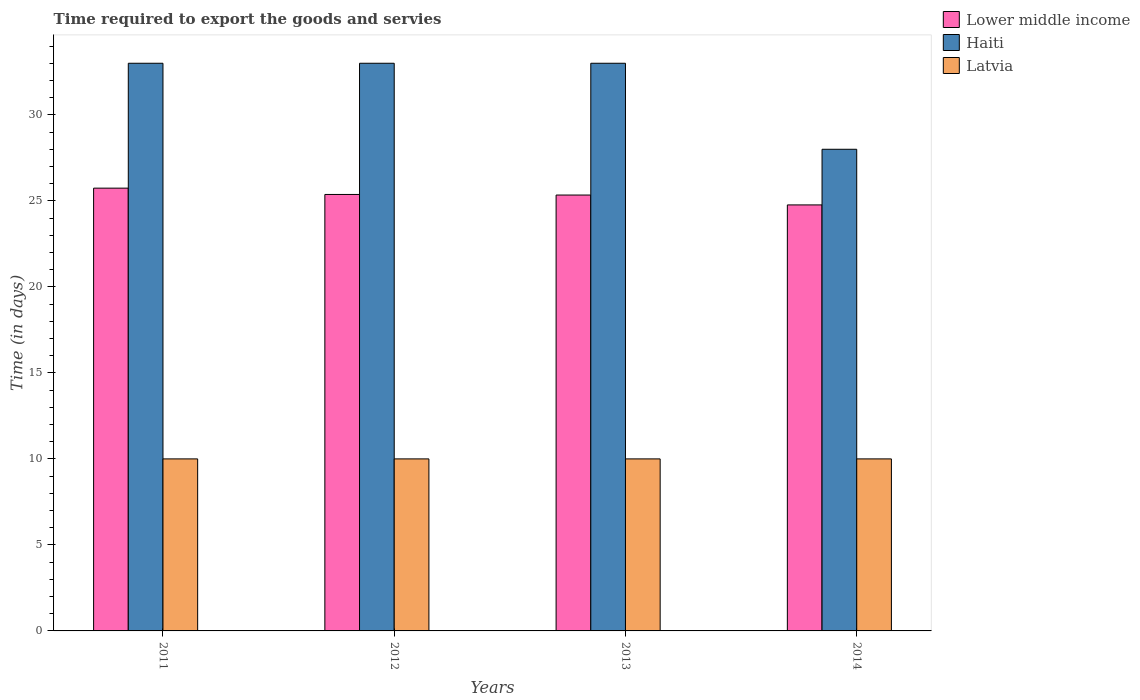Are the number of bars per tick equal to the number of legend labels?
Ensure brevity in your answer.  Yes. Are the number of bars on each tick of the X-axis equal?
Your response must be concise. Yes. What is the number of days required to export the goods and services in Haiti in 2011?
Give a very brief answer. 33. Across all years, what is the maximum number of days required to export the goods and services in Lower middle income?
Keep it short and to the point. 25.74. Across all years, what is the minimum number of days required to export the goods and services in Latvia?
Your answer should be very brief. 10. In which year was the number of days required to export the goods and services in Latvia minimum?
Your answer should be very brief. 2011. What is the total number of days required to export the goods and services in Haiti in the graph?
Offer a very short reply. 127. What is the difference between the number of days required to export the goods and services in Lower middle income in 2013 and that in 2014?
Provide a short and direct response. 0.57. What is the difference between the number of days required to export the goods and services in Latvia in 2011 and the number of days required to export the goods and services in Lower middle income in 2012?
Offer a terse response. -15.37. What is the average number of days required to export the goods and services in Latvia per year?
Give a very brief answer. 10. In the year 2013, what is the difference between the number of days required to export the goods and services in Lower middle income and number of days required to export the goods and services in Haiti?
Your answer should be compact. -7.66. In how many years, is the number of days required to export the goods and services in Latvia greater than 7 days?
Provide a succinct answer. 4. What is the ratio of the number of days required to export the goods and services in Haiti in 2012 to that in 2013?
Your answer should be very brief. 1. Is the number of days required to export the goods and services in Lower middle income in 2011 less than that in 2013?
Keep it short and to the point. No. What is the difference between the highest and the second highest number of days required to export the goods and services in Lower middle income?
Your answer should be very brief. 0.37. Is the sum of the number of days required to export the goods and services in Haiti in 2012 and 2013 greater than the maximum number of days required to export the goods and services in Latvia across all years?
Offer a terse response. Yes. What does the 3rd bar from the left in 2011 represents?
Provide a short and direct response. Latvia. What does the 1st bar from the right in 2014 represents?
Provide a succinct answer. Latvia. Is it the case that in every year, the sum of the number of days required to export the goods and services in Haiti and number of days required to export the goods and services in Lower middle income is greater than the number of days required to export the goods and services in Latvia?
Offer a terse response. Yes. How many bars are there?
Offer a terse response. 12. How many years are there in the graph?
Make the answer very short. 4. Does the graph contain grids?
Offer a terse response. No. How many legend labels are there?
Your answer should be very brief. 3. What is the title of the graph?
Your response must be concise. Time required to export the goods and servies. Does "Chile" appear as one of the legend labels in the graph?
Make the answer very short. No. What is the label or title of the Y-axis?
Offer a terse response. Time (in days). What is the Time (in days) of Lower middle income in 2011?
Provide a short and direct response. 25.74. What is the Time (in days) of Haiti in 2011?
Provide a succinct answer. 33. What is the Time (in days) in Lower middle income in 2012?
Offer a very short reply. 25.37. What is the Time (in days) in Lower middle income in 2013?
Your answer should be compact. 25.34. What is the Time (in days) of Lower middle income in 2014?
Provide a short and direct response. 24.76. What is the Time (in days) in Latvia in 2014?
Offer a terse response. 10. Across all years, what is the maximum Time (in days) of Lower middle income?
Offer a terse response. 25.74. Across all years, what is the maximum Time (in days) in Latvia?
Provide a short and direct response. 10. Across all years, what is the minimum Time (in days) of Lower middle income?
Give a very brief answer. 24.76. Across all years, what is the minimum Time (in days) in Haiti?
Your answer should be very brief. 28. What is the total Time (in days) in Lower middle income in the graph?
Your answer should be compact. 101.22. What is the total Time (in days) of Haiti in the graph?
Offer a terse response. 127. What is the total Time (in days) of Latvia in the graph?
Your response must be concise. 40. What is the difference between the Time (in days) of Lower middle income in 2011 and that in 2012?
Keep it short and to the point. 0.37. What is the difference between the Time (in days) in Latvia in 2011 and that in 2012?
Keep it short and to the point. 0. What is the difference between the Time (in days) in Lower middle income in 2011 and that in 2013?
Your answer should be very brief. 0.4. What is the difference between the Time (in days) in Lower middle income in 2011 and that in 2014?
Make the answer very short. 0.98. What is the difference between the Time (in days) in Latvia in 2012 and that in 2013?
Ensure brevity in your answer.  0. What is the difference between the Time (in days) in Lower middle income in 2012 and that in 2014?
Offer a very short reply. 0.61. What is the difference between the Time (in days) of Lower middle income in 2013 and that in 2014?
Give a very brief answer. 0.57. What is the difference between the Time (in days) in Haiti in 2013 and that in 2014?
Your answer should be very brief. 5. What is the difference between the Time (in days) in Lower middle income in 2011 and the Time (in days) in Haiti in 2012?
Your response must be concise. -7.26. What is the difference between the Time (in days) of Lower middle income in 2011 and the Time (in days) of Latvia in 2012?
Your response must be concise. 15.74. What is the difference between the Time (in days) of Lower middle income in 2011 and the Time (in days) of Haiti in 2013?
Your answer should be compact. -7.26. What is the difference between the Time (in days) of Lower middle income in 2011 and the Time (in days) of Latvia in 2013?
Your answer should be compact. 15.74. What is the difference between the Time (in days) of Haiti in 2011 and the Time (in days) of Latvia in 2013?
Your answer should be very brief. 23. What is the difference between the Time (in days) in Lower middle income in 2011 and the Time (in days) in Haiti in 2014?
Ensure brevity in your answer.  -2.26. What is the difference between the Time (in days) in Lower middle income in 2011 and the Time (in days) in Latvia in 2014?
Offer a terse response. 15.74. What is the difference between the Time (in days) in Lower middle income in 2012 and the Time (in days) in Haiti in 2013?
Your answer should be compact. -7.63. What is the difference between the Time (in days) of Lower middle income in 2012 and the Time (in days) of Latvia in 2013?
Your answer should be compact. 15.37. What is the difference between the Time (in days) of Haiti in 2012 and the Time (in days) of Latvia in 2013?
Your answer should be compact. 23. What is the difference between the Time (in days) in Lower middle income in 2012 and the Time (in days) in Haiti in 2014?
Offer a terse response. -2.63. What is the difference between the Time (in days) in Lower middle income in 2012 and the Time (in days) in Latvia in 2014?
Offer a very short reply. 15.37. What is the difference between the Time (in days) in Lower middle income in 2013 and the Time (in days) in Haiti in 2014?
Your answer should be very brief. -2.66. What is the difference between the Time (in days) in Lower middle income in 2013 and the Time (in days) in Latvia in 2014?
Offer a very short reply. 15.34. What is the difference between the Time (in days) of Haiti in 2013 and the Time (in days) of Latvia in 2014?
Offer a terse response. 23. What is the average Time (in days) of Lower middle income per year?
Your response must be concise. 25.3. What is the average Time (in days) of Haiti per year?
Your answer should be very brief. 31.75. What is the average Time (in days) in Latvia per year?
Make the answer very short. 10. In the year 2011, what is the difference between the Time (in days) of Lower middle income and Time (in days) of Haiti?
Provide a short and direct response. -7.26. In the year 2011, what is the difference between the Time (in days) of Lower middle income and Time (in days) of Latvia?
Your answer should be compact. 15.74. In the year 2011, what is the difference between the Time (in days) in Haiti and Time (in days) in Latvia?
Give a very brief answer. 23. In the year 2012, what is the difference between the Time (in days) of Lower middle income and Time (in days) of Haiti?
Give a very brief answer. -7.63. In the year 2012, what is the difference between the Time (in days) in Lower middle income and Time (in days) in Latvia?
Give a very brief answer. 15.37. In the year 2013, what is the difference between the Time (in days) in Lower middle income and Time (in days) in Haiti?
Your answer should be very brief. -7.66. In the year 2013, what is the difference between the Time (in days) in Lower middle income and Time (in days) in Latvia?
Your answer should be compact. 15.34. In the year 2014, what is the difference between the Time (in days) in Lower middle income and Time (in days) in Haiti?
Offer a very short reply. -3.24. In the year 2014, what is the difference between the Time (in days) of Lower middle income and Time (in days) of Latvia?
Give a very brief answer. 14.76. What is the ratio of the Time (in days) in Lower middle income in 2011 to that in 2012?
Give a very brief answer. 1.01. What is the ratio of the Time (in days) in Haiti in 2011 to that in 2012?
Give a very brief answer. 1. What is the ratio of the Time (in days) in Latvia in 2011 to that in 2012?
Provide a succinct answer. 1. What is the ratio of the Time (in days) in Lower middle income in 2011 to that in 2013?
Offer a terse response. 1.02. What is the ratio of the Time (in days) in Lower middle income in 2011 to that in 2014?
Your answer should be compact. 1.04. What is the ratio of the Time (in days) in Haiti in 2011 to that in 2014?
Your answer should be compact. 1.18. What is the ratio of the Time (in days) of Latvia in 2011 to that in 2014?
Keep it short and to the point. 1. What is the ratio of the Time (in days) of Lower middle income in 2012 to that in 2013?
Make the answer very short. 1. What is the ratio of the Time (in days) of Lower middle income in 2012 to that in 2014?
Provide a succinct answer. 1.02. What is the ratio of the Time (in days) of Haiti in 2012 to that in 2014?
Ensure brevity in your answer.  1.18. What is the ratio of the Time (in days) in Latvia in 2012 to that in 2014?
Provide a short and direct response. 1. What is the ratio of the Time (in days) in Lower middle income in 2013 to that in 2014?
Keep it short and to the point. 1.02. What is the ratio of the Time (in days) of Haiti in 2013 to that in 2014?
Provide a succinct answer. 1.18. What is the ratio of the Time (in days) in Latvia in 2013 to that in 2014?
Offer a very short reply. 1. What is the difference between the highest and the second highest Time (in days) in Lower middle income?
Give a very brief answer. 0.37. What is the difference between the highest and the second highest Time (in days) in Haiti?
Ensure brevity in your answer.  0. What is the difference between the highest and the second highest Time (in days) in Latvia?
Ensure brevity in your answer.  0. What is the difference between the highest and the lowest Time (in days) of Lower middle income?
Offer a very short reply. 0.98. 